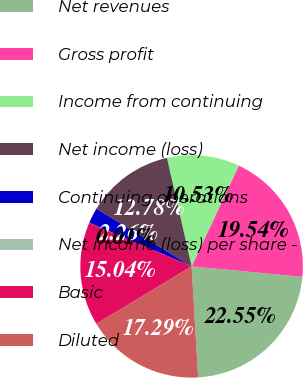Convert chart to OTSL. <chart><loc_0><loc_0><loc_500><loc_500><pie_chart><fcel>Net revenues<fcel>Gross profit<fcel>Income from continuing<fcel>Net income (loss)<fcel>Continuing operations<fcel>Net income (loss) per share -<fcel>Basic<fcel>Diluted<nl><fcel>22.55%<fcel>19.54%<fcel>10.53%<fcel>12.78%<fcel>2.26%<fcel>0.01%<fcel>15.04%<fcel>17.29%<nl></chart> 